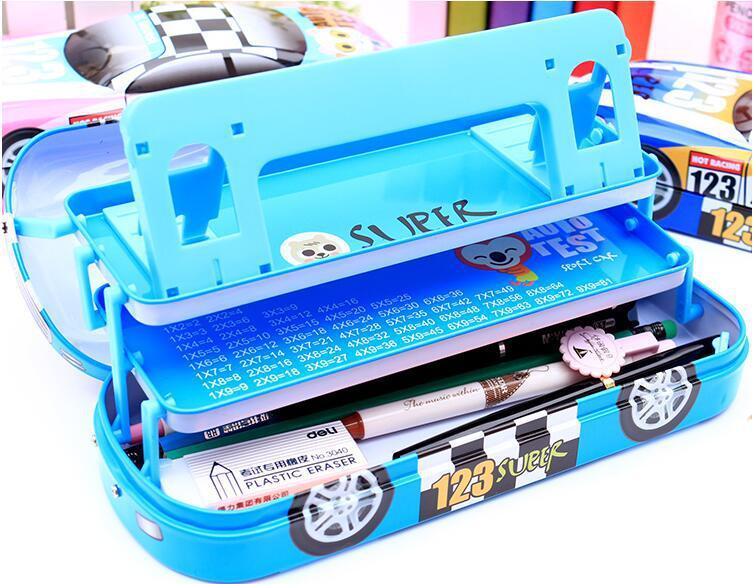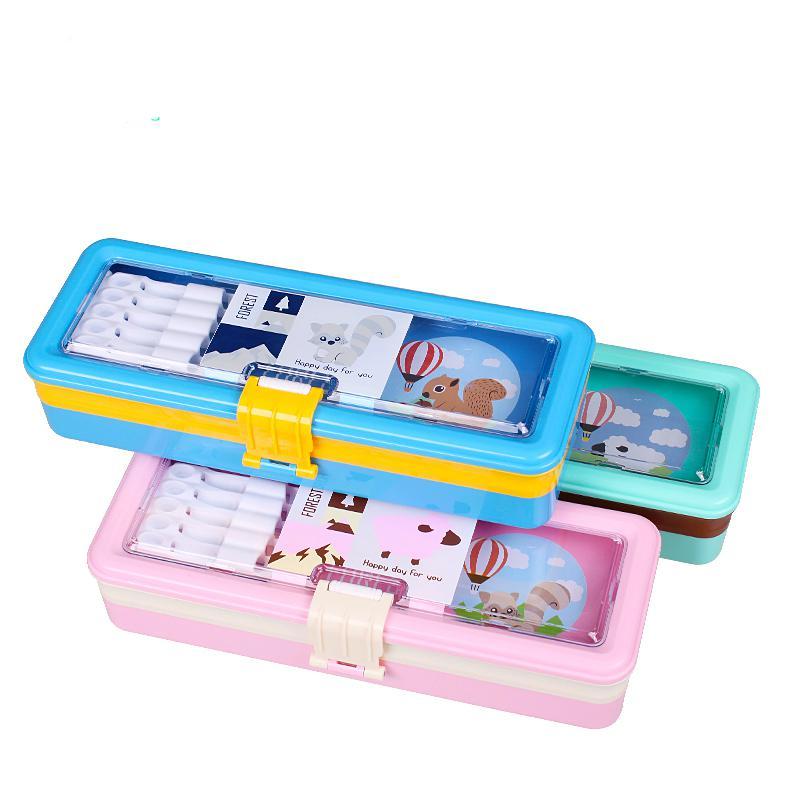The first image is the image on the left, the second image is the image on the right. Evaluate the accuracy of this statement regarding the images: "There is at least one pen inside an open 3 layered pencil case.". Is it true? Answer yes or no. Yes. The first image is the image on the left, the second image is the image on the right. Given the left and right images, does the statement "An image shows three variations of the same kind of case, each a different color." hold true? Answer yes or no. Yes. 